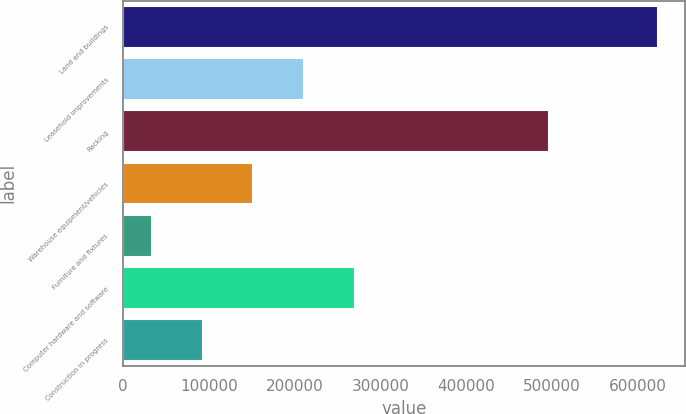<chart> <loc_0><loc_0><loc_500><loc_500><bar_chart><fcel>Land and buildings<fcel>Leasehold improvements<fcel>Racking<fcel>Warehouse equipment/vehicles<fcel>Furniture and fixtures<fcel>Computer hardware and software<fcel>Construction in progress<nl><fcel>623717<fcel>210919<fcel>496919<fcel>151947<fcel>34005<fcel>269890<fcel>92976.2<nl></chart> 